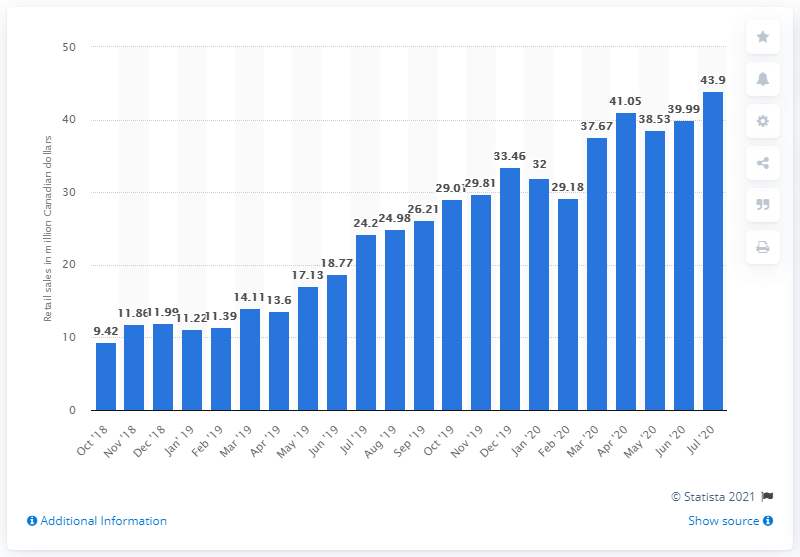Draw attention to some important aspects in this diagram. In July of 2020, the monthly sales of cannabis in Quebec were 43.9 million dollars. 